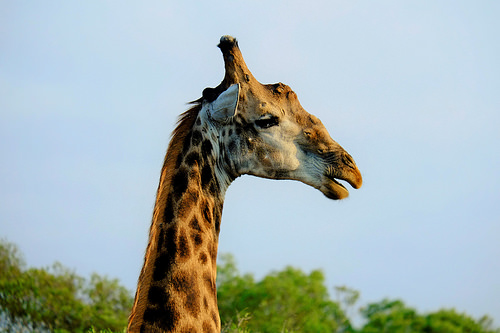<image>
Can you confirm if the giraffe is to the left of the trees? No. The giraffe is not to the left of the trees. From this viewpoint, they have a different horizontal relationship. Is the sky behind the giraffe? Yes. From this viewpoint, the sky is positioned behind the giraffe, with the giraffe partially or fully occluding the sky. Is there a tree in front of the giraffe? No. The tree is not in front of the giraffe. The spatial positioning shows a different relationship between these objects. 